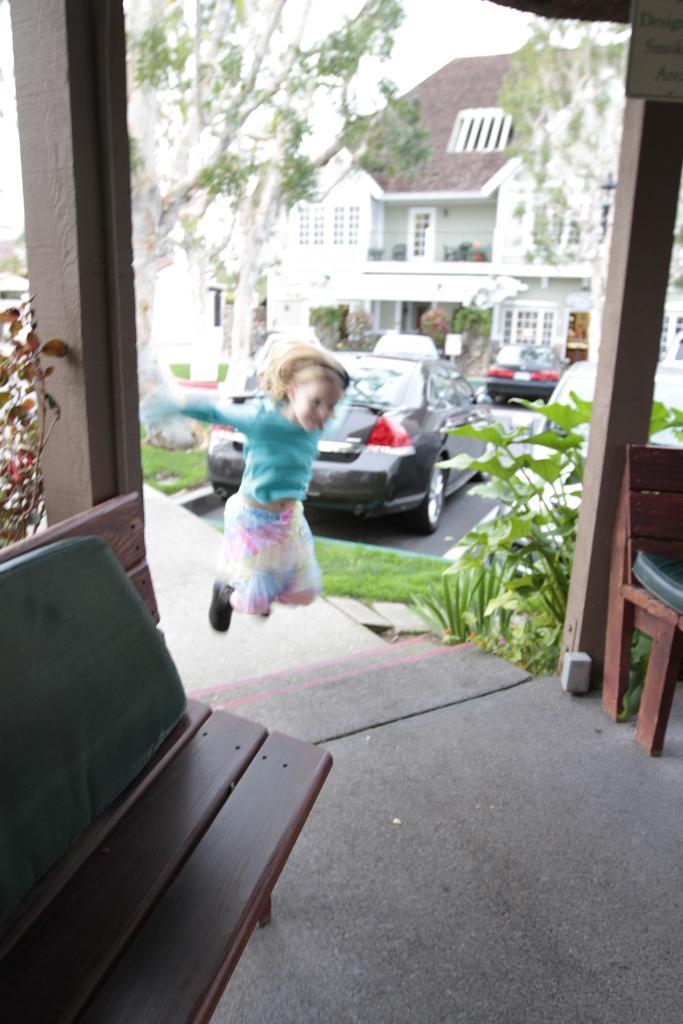What type of seating is present in the image? There is a bench in the image. What is the girl in the image doing? The girl is jumping in the image. What can be seen in the distance behind the girl? There are cars, buildings, and trees visible in the background of the image. How many cattle are present in the image? There are no cattle present in the image. What type of transport is being used by the cattle in the image? There are no cattle or transport present in the image. 